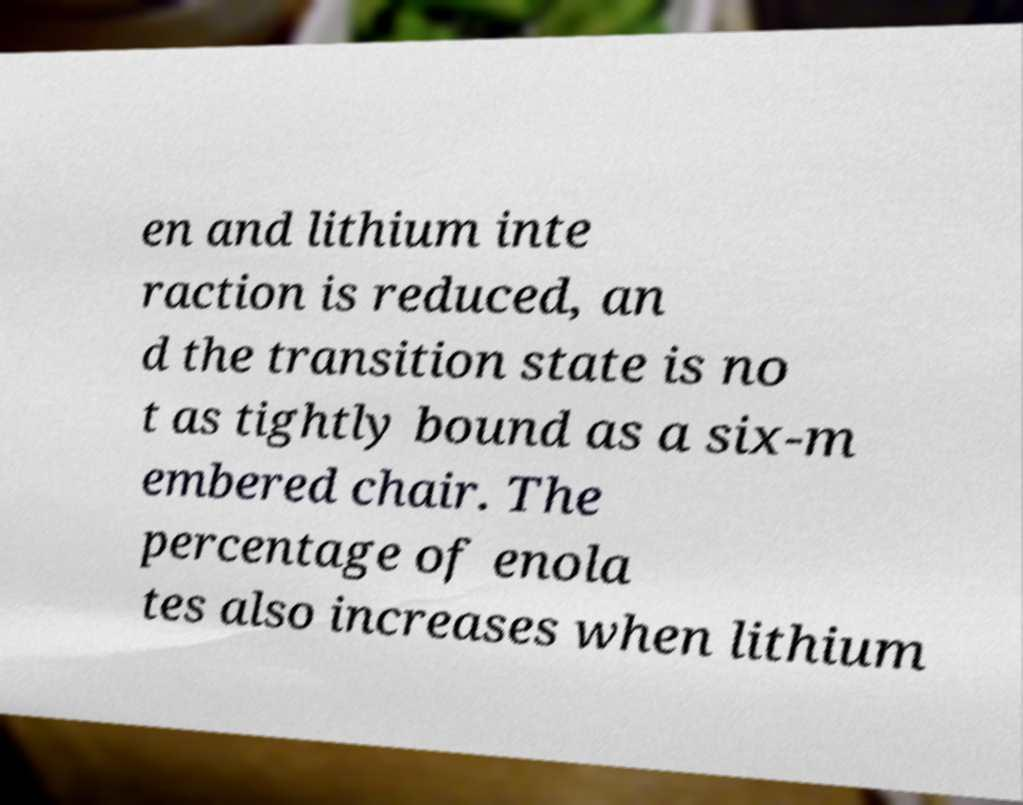For documentation purposes, I need the text within this image transcribed. Could you provide that? en and lithium inte raction is reduced, an d the transition state is no t as tightly bound as a six-m embered chair. The percentage of enola tes also increases when lithium 